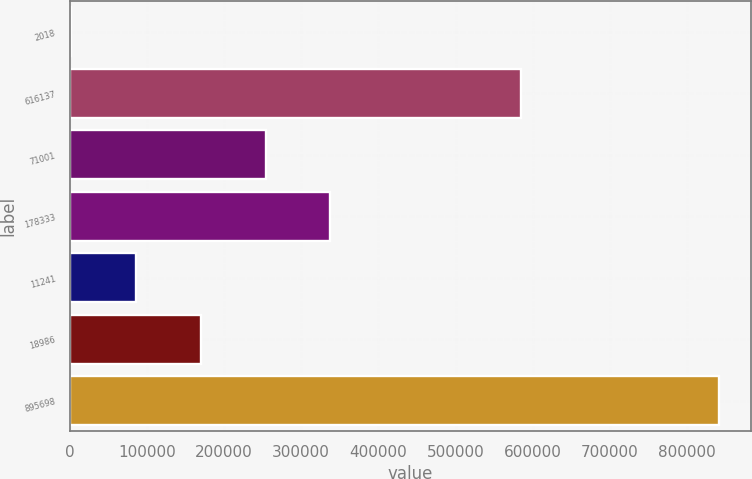<chart> <loc_0><loc_0><loc_500><loc_500><bar_chart><fcel>2018<fcel>616137<fcel>71001<fcel>178333<fcel>11241<fcel>18986<fcel>895698<nl><fcel>2017<fcel>585178<fcel>253850<fcel>337795<fcel>85961.4<fcel>169906<fcel>841461<nl></chart> 